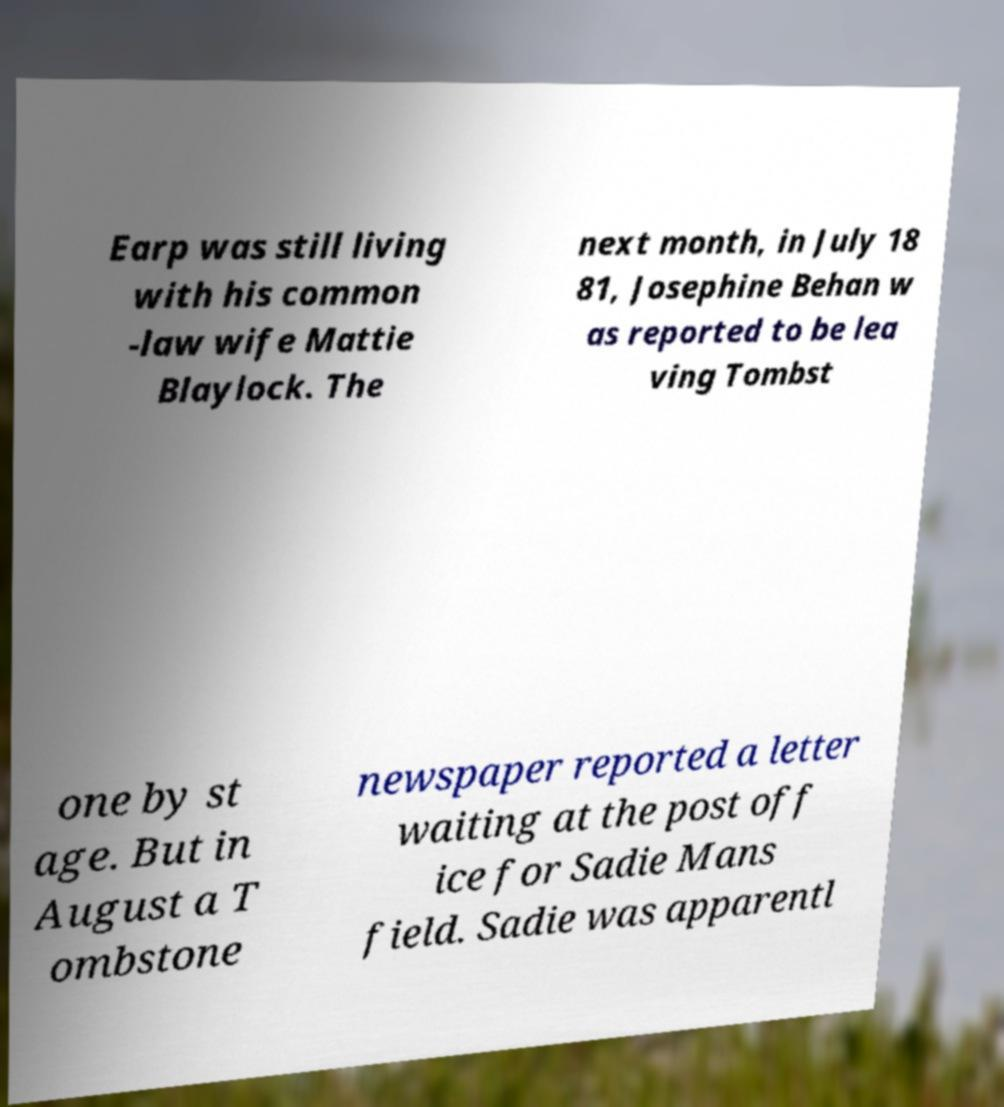What messages or text are displayed in this image? I need them in a readable, typed format. Earp was still living with his common -law wife Mattie Blaylock. The next month, in July 18 81, Josephine Behan w as reported to be lea ving Tombst one by st age. But in August a T ombstone newspaper reported a letter waiting at the post off ice for Sadie Mans field. Sadie was apparentl 